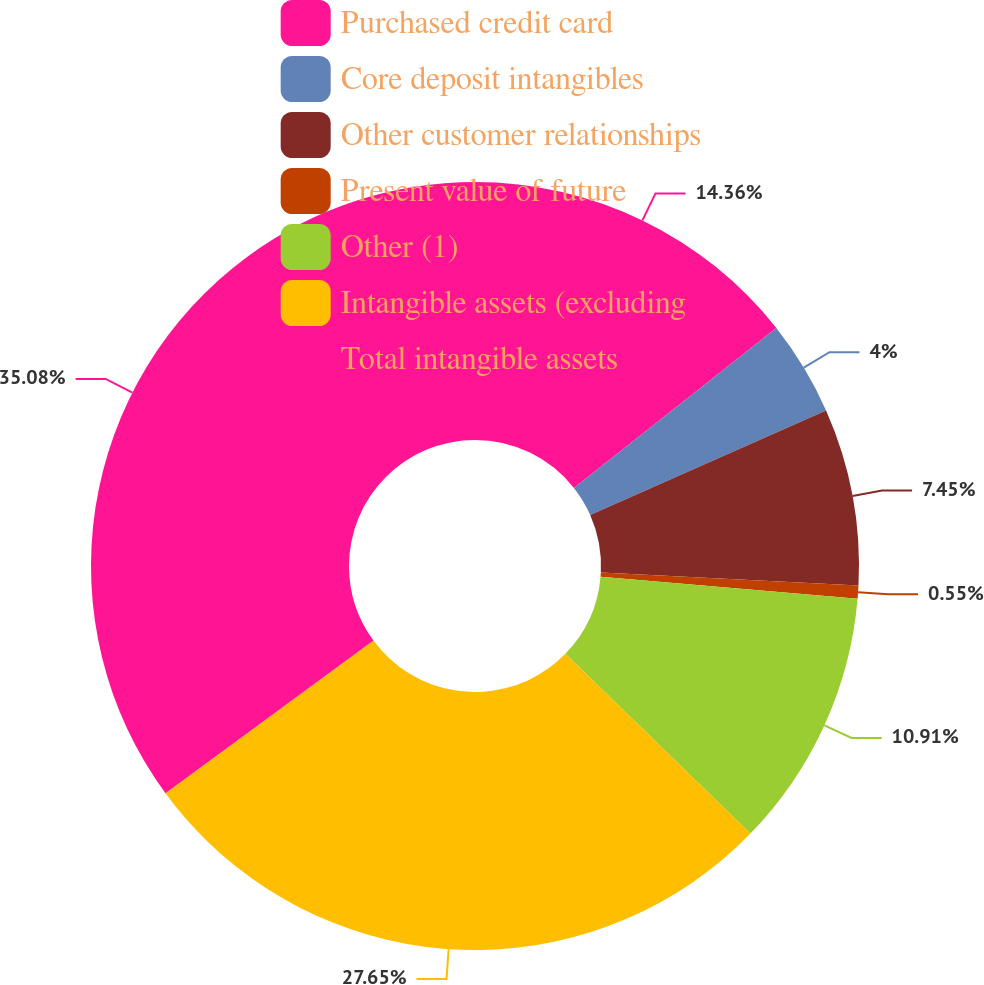Convert chart. <chart><loc_0><loc_0><loc_500><loc_500><pie_chart><fcel>Purchased credit card<fcel>Core deposit intangibles<fcel>Other customer relationships<fcel>Present value of future<fcel>Other (1)<fcel>Intangible assets (excluding<fcel>Total intangible assets<nl><fcel>14.36%<fcel>4.0%<fcel>7.45%<fcel>0.55%<fcel>10.91%<fcel>27.65%<fcel>35.08%<nl></chart> 